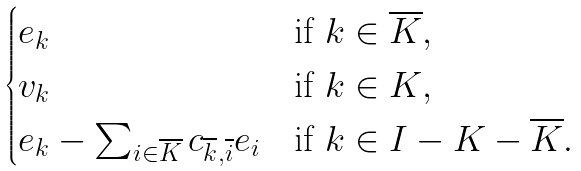Convert formula to latex. <formula><loc_0><loc_0><loc_500><loc_500>\begin{cases} e _ { k } & \text {if $k\in \overline{K}$} , \\ v _ { k } & \text {if $k\in K$} , \\ e _ { k } - \sum _ { i \in \overline { K } } c _ { \overline { k } , \overline { i } } e _ { i } & \text {if $k\in I-K-\overline{K}$} . \end{cases}</formula> 